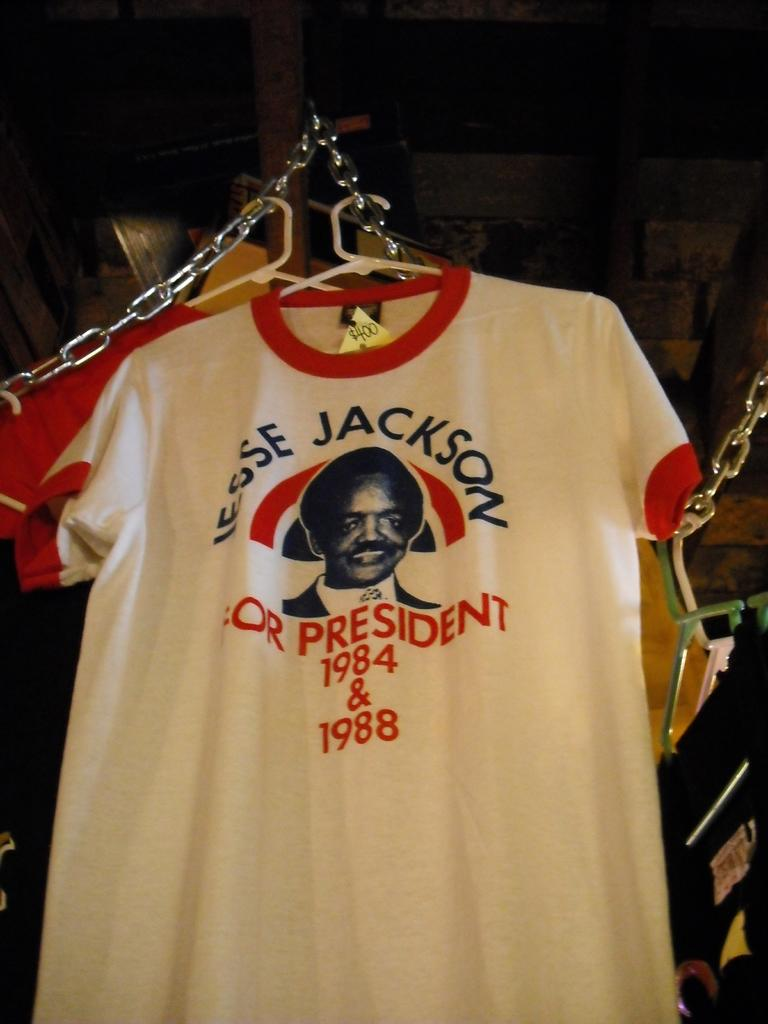<image>
Present a compact description of the photo's key features. Tshirts hanging with first tishirt saying "JESSE JACKSON PRESIDENT 1984 & 1988" 